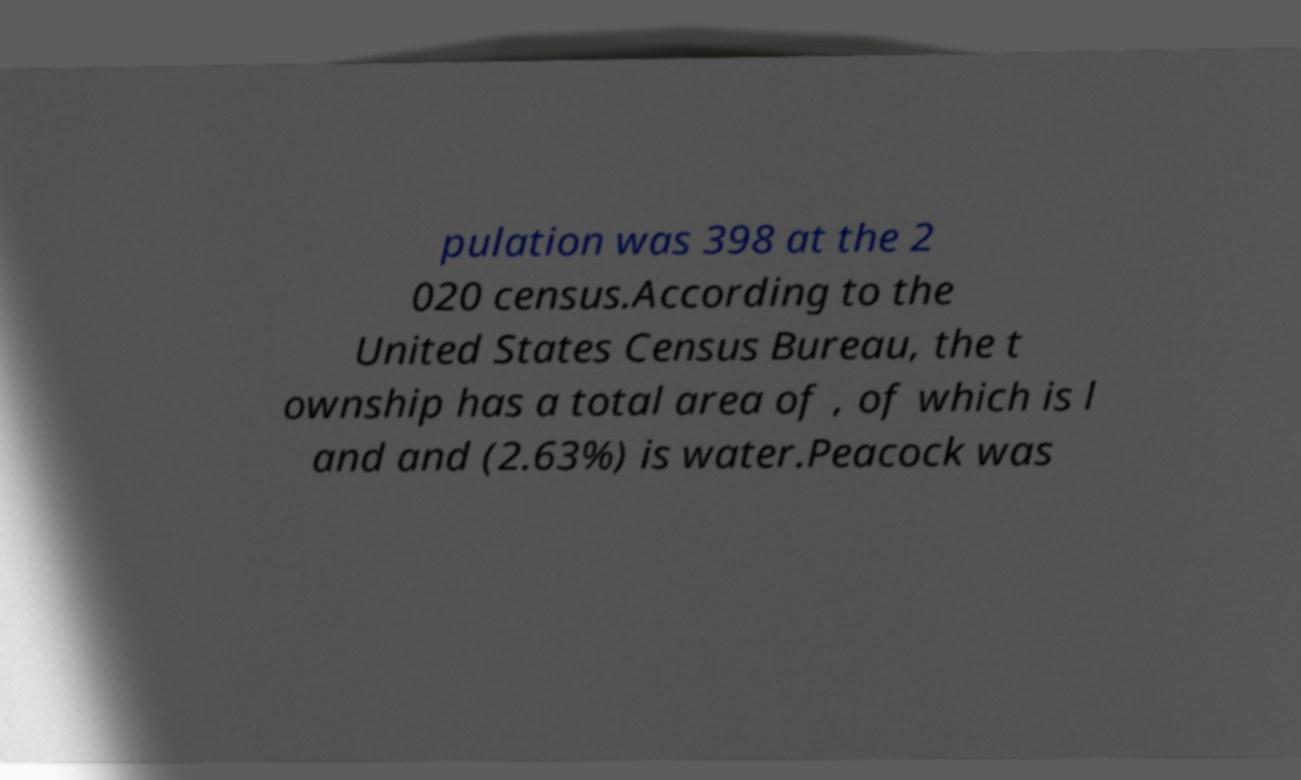For documentation purposes, I need the text within this image transcribed. Could you provide that? pulation was 398 at the 2 020 census.According to the United States Census Bureau, the t ownship has a total area of , of which is l and and (2.63%) is water.Peacock was 